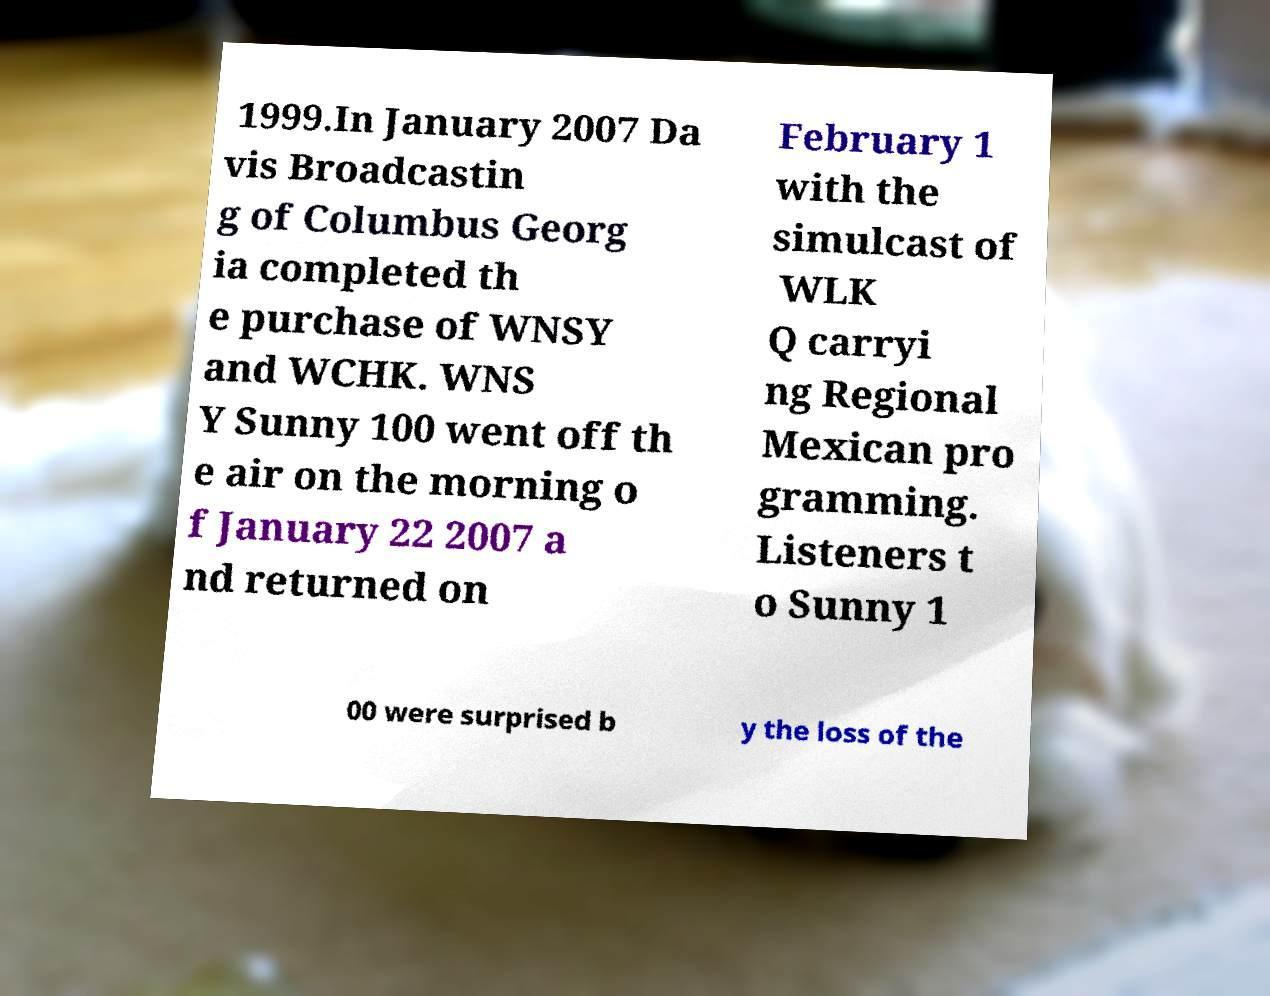Can you read and provide the text displayed in the image?This photo seems to have some interesting text. Can you extract and type it out for me? 1999.In January 2007 Da vis Broadcastin g of Columbus Georg ia completed th e purchase of WNSY and WCHK. WNS Y Sunny 100 went off th e air on the morning o f January 22 2007 a nd returned on February 1 with the simulcast of WLK Q carryi ng Regional Mexican pro gramming. Listeners t o Sunny 1 00 were surprised b y the loss of the 